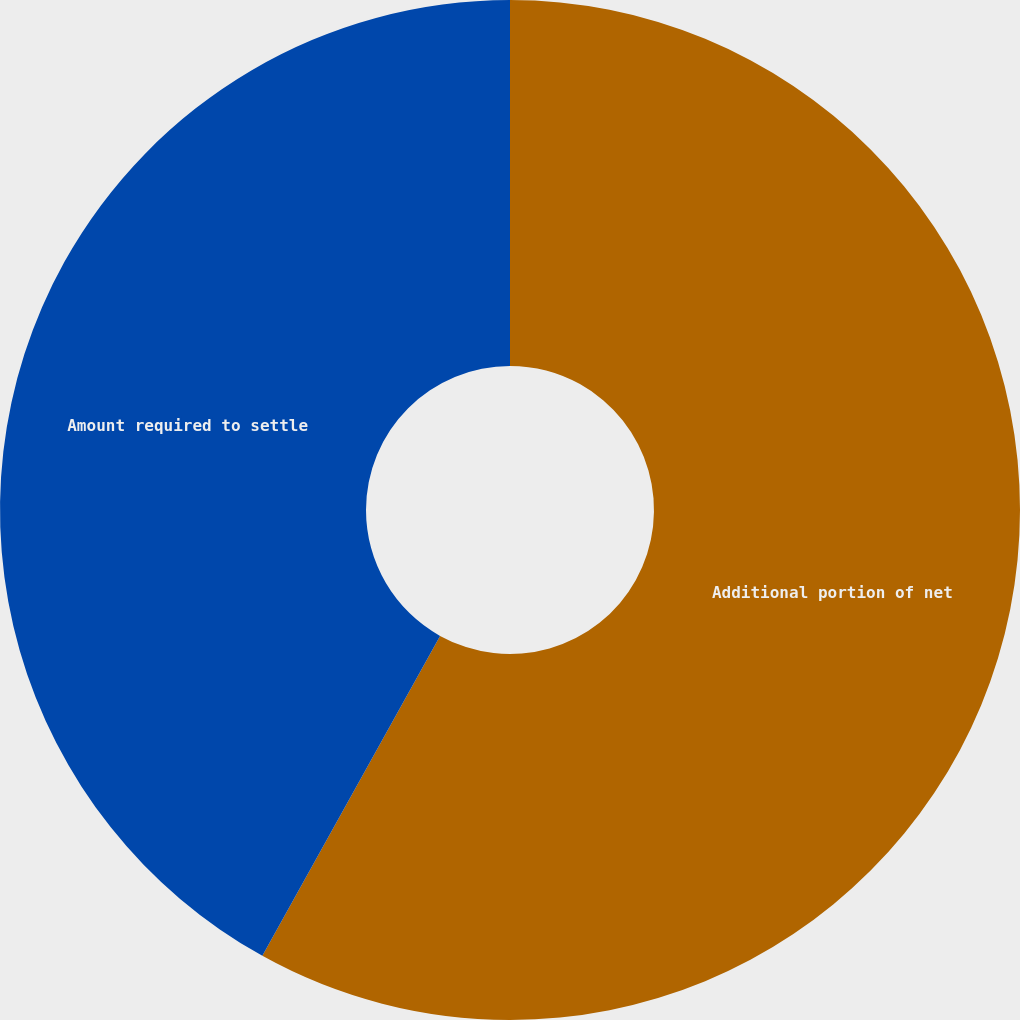<chart> <loc_0><loc_0><loc_500><loc_500><pie_chart><fcel>Additional portion of net<fcel>Amount required to settle<nl><fcel>58.07%<fcel>41.93%<nl></chart> 